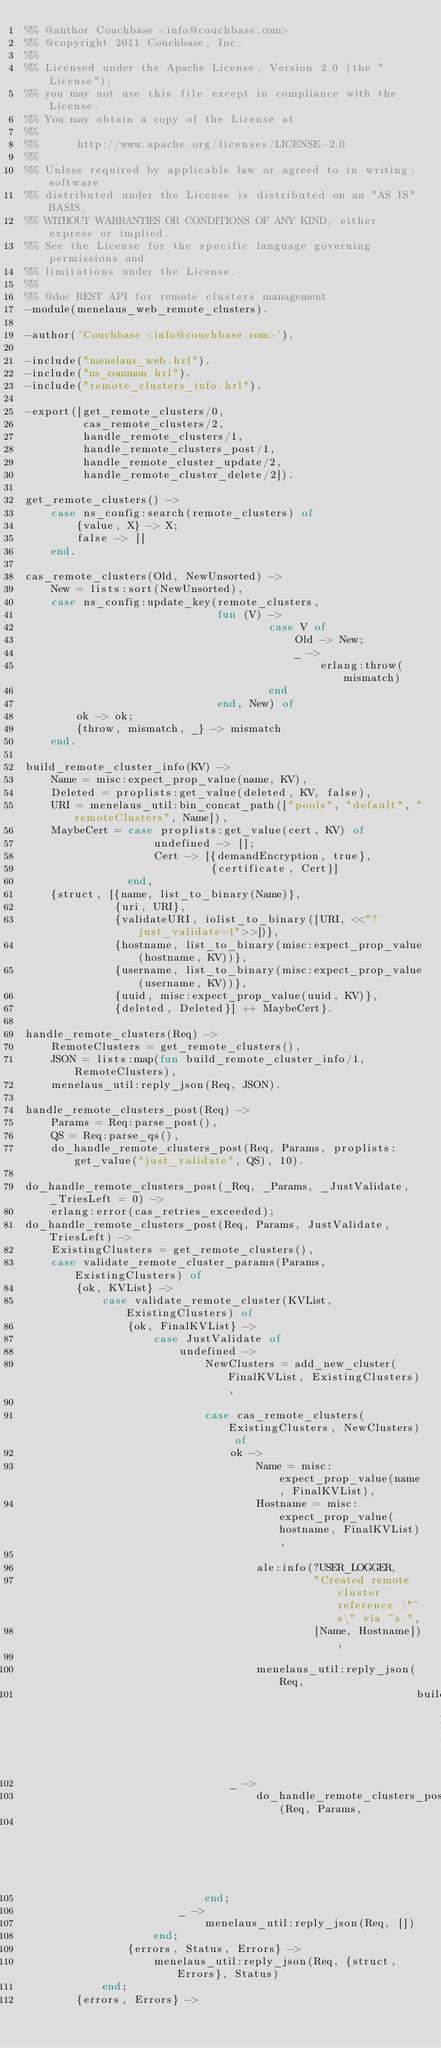<code> <loc_0><loc_0><loc_500><loc_500><_Erlang_>%% @author Couchbase <info@couchbase.com>
%% @copyright 2011 Couchbase, Inc.
%%
%% Licensed under the Apache License, Version 2.0 (the "License");
%% you may not use this file except in compliance with the License.
%% You may obtain a copy of the License at
%%
%%      http://www.apache.org/licenses/LICENSE-2.0
%%
%% Unless required by applicable law or agreed to in writing, software
%% distributed under the License is distributed on an "AS IS" BASIS,
%% WITHOUT WARRANTIES OR CONDITIONS OF ANY KIND, either express or implied.
%% See the License for the specific language governing permissions and
%% limitations under the License.
%%
%% @doc REST API for remote clusters management
-module(menelaus_web_remote_clusters).

-author('Couchbase <info@couchbase.com>').

-include("menelaus_web.hrl").
-include("ns_common.hrl").
-include("remote_clusters_info.hrl").

-export([get_remote_clusters/0,
         cas_remote_clusters/2,
         handle_remote_clusters/1,
         handle_remote_clusters_post/1,
         handle_remote_cluster_update/2,
         handle_remote_cluster_delete/2]).

get_remote_clusters() ->
    case ns_config:search(remote_clusters) of
        {value, X} -> X;
        false -> []
    end.

cas_remote_clusters(Old, NewUnsorted) ->
    New = lists:sort(NewUnsorted),
    case ns_config:update_key(remote_clusters,
                              fun (V) ->
                                      case V of
                                          Old -> New;
                                          _ ->
                                              erlang:throw(mismatch)
                                      end
                              end, New) of
        ok -> ok;
        {throw, mismatch, _} -> mismatch
    end.

build_remote_cluster_info(KV) ->
    Name = misc:expect_prop_value(name, KV),
    Deleted = proplists:get_value(deleted, KV, false),
    URI = menelaus_util:bin_concat_path(["pools", "default", "remoteClusters", Name]),
    MaybeCert = case proplists:get_value(cert, KV) of
                    undefined -> [];
                    Cert -> [{demandEncryption, true},
                             {certificate, Cert}]
                end,
    {struct, [{name, list_to_binary(Name)},
              {uri, URI},
              {validateURI, iolist_to_binary([URI, <<"?just_validate=1">>])},
              {hostname, list_to_binary(misc:expect_prop_value(hostname, KV))},
              {username, list_to_binary(misc:expect_prop_value(username, KV))},
              {uuid, misc:expect_prop_value(uuid, KV)},
              {deleted, Deleted}] ++ MaybeCert}.

handle_remote_clusters(Req) ->
    RemoteClusters = get_remote_clusters(),
    JSON = lists:map(fun build_remote_cluster_info/1, RemoteClusters),
    menelaus_util:reply_json(Req, JSON).

handle_remote_clusters_post(Req) ->
    Params = Req:parse_post(),
    QS = Req:parse_qs(),
    do_handle_remote_clusters_post(Req, Params, proplists:get_value("just_validate", QS), 10).

do_handle_remote_clusters_post(_Req, _Params, _JustValidate, _TriesLeft = 0) ->
    erlang:error(cas_retries_exceeded);
do_handle_remote_clusters_post(Req, Params, JustValidate, TriesLeft) ->
    ExistingClusters = get_remote_clusters(),
    case validate_remote_cluster_params(Params, ExistingClusters) of
        {ok, KVList} ->
            case validate_remote_cluster(KVList, ExistingClusters) of
                {ok, FinalKVList} ->
                    case JustValidate of
                        undefined ->
                            NewClusters = add_new_cluster(FinalKVList, ExistingClusters),

                            case cas_remote_clusters(ExistingClusters, NewClusters) of
                                ok ->
                                    Name = misc:expect_prop_value(name, FinalKVList),
                                    Hostname = misc:expect_prop_value(hostname, FinalKVList),

                                    ale:info(?USER_LOGGER,
                                             "Created remote cluster reference \"~s\" via ~s.",
                                             [Name, Hostname]),

                                    menelaus_util:reply_json(Req,
                                                             build_remote_cluster_info(FinalKVList));
                                _ ->
                                    do_handle_remote_clusters_post(Req, Params,
                                                                   JustValidate, TriesLeft-1)
                            end;
                        _ ->
                            menelaus_util:reply_json(Req, [])
                    end;
                {errors, Status, Errors} ->
                    menelaus_util:reply_json(Req, {struct, Errors}, Status)
            end;
        {errors, Errors} -></code> 